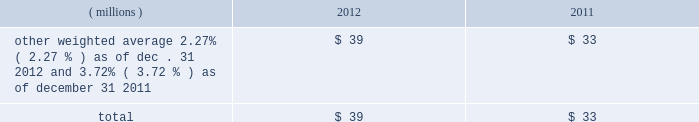2012 ppg annual report and form 10-k 45 costs related to these notes , which totaled $ 17 million , will be amortized to interest expense over the respective terms of the notes .
In august 2010 , ppg entered into a three-year credit agreement with several banks and financial institutions ( the "2010 credit agreement" ) which was subsequently terminated in july 2012 .
The 2010 credit agreement provided for a $ 1.2 billion unsecured revolving credit facility .
In connection with entering into the 2010 credit agreement , the company terminated its 20ac650 million and its $ 1 billion revolving credit facilities that were each set to expire in 2011 .
There were no outstanding amounts due under either revolving facility at the times of their termination .
The 2010 credit agreement was set to terminate on august 5 , 2013 .
Ppg 2019s non-u.s .
Operations have uncommitted lines of credit totaling $ 705 million of which $ 34 million was used as of december 31 , 2012 .
These uncommitted lines of credit are subject to cancellation at any time and are generally not subject to any commitment fees .
Short-term debt outstanding as of december 31 , 2012 and 2011 , was as follows: .
Ppg is in compliance with the restrictive covenants under its various credit agreements , loan agreements and indentures .
The company 2019s revolving credit agreements include a financial ratio covenant .
The covenant requires that the amount of total indebtedness not exceed 60% ( 60 % ) of the company 2019s total capitalization excluding the portion of accumulated other comprehensive income ( loss ) related to pensions and other postretirement benefit adjustments .
As of december 31 , 2012 , total indebtedness was 42% ( 42 % ) of the company 2019s total capitalization excluding the portion of accumulated other comprehensive income ( loss ) related to pensions and other postretirement benefit adjustments .
Additionally , substantially all of the company 2019s debt agreements contain customary cross- default provisions .
Those provisions generally provide that a default on a debt service payment of $ 10 million or more for longer than the grace period provided ( usually 10 days ) under one agreement may result in an event of default under other agreements .
None of the company 2019s primary debt obligations are secured or guaranteed by the company 2019s affiliates .
Interest payments in 2012 , 2011 and 2010 totaled $ 219 million , $ 212 million and $ 189 million , respectively .
In october 2009 , the company entered into an agreement with a counterparty to repurchase up to 1.2 million shares of the company 2019s stock of which 1.1 million shares were purchased in the open market ( 465006 of these shares were purchased as of december 31 , 2009 at a weighted average price of $ 56.66 per share ) .
The counterparty held the shares until september of 2010 when the company paid $ 65 million and took possession of these shares .
Rental expense for operating leases was $ 233 million , $ 249 million and $ 233 million in 2012 , 2011 and 2010 , respectively .
The primary leased assets include paint stores , transportation equipment , warehouses and other distribution facilities , and office space , including the company 2019s corporate headquarters located in pittsburgh , pa .
Minimum lease commitments for operating leases that have initial or remaining lease terms in excess of one year as of december 31 , 2012 , are ( in millions ) $ 171 in 2013 , $ 135 in 2014 , $ 107 in 2015 , $ 83 in 2016 , $ 64 in 2017 and $ 135 thereafter .
The company had outstanding letters of credit and surety bonds of $ 119 million as of december 31 , 2012 .
The letters of credit secure the company 2019s performance to third parties under certain self-insurance programs and other commitments made in the ordinary course of business .
As of december 31 , 2012 and 2011 , guarantees outstanding were $ 96 million and $ 90 million , respectively .
The guarantees relate primarily to debt of certain entities in which ppg has an ownership interest and selected customers of certain of the company 2019s businesses .
A portion of such debt is secured by the assets of the related entities .
The carrying values of these guarantees were $ 11 million and $ 13 million as of december 31 , 2012 and 2011 , respectively , and the fair values were $ 11 million and $ 21 million , as of december 31 , 2012 and 2011 , respectively .
The fair value of each guarantee was estimated by comparing the net present value of two hypothetical cash flow streams , one based on ppg 2019s incremental borrowing rate and the other based on the borrower 2019s incremental borrowing rate , as of the effective date of the guarantee .
Both streams were discounted at a risk free rate of return .
The company does not believe any loss related to these letters of credit , surety bonds or guarantees is likely .
Fair value measurement the accounting guidance on fair value measurements establishes a hierarchy with three levels of inputs used to determine fair value .
Level 1 inputs are quoted prices ( unadjusted ) in active markets for identical assets and liabilities , are considered to be the most reliable evidence of fair value , and should be used whenever available .
Level 2 inputs are observable prices that are not quoted on active exchanges .
Level 3 inputs are unobservable inputs employed for measuring the fair value of assets or liabilities .
Table of contents notes to the consolidated financial statements .
What was the percentage change in rental expense for operating leases from 2010 to 2011? 
Computations: ((249 - 233) / 233)
Answer: 0.06867. 